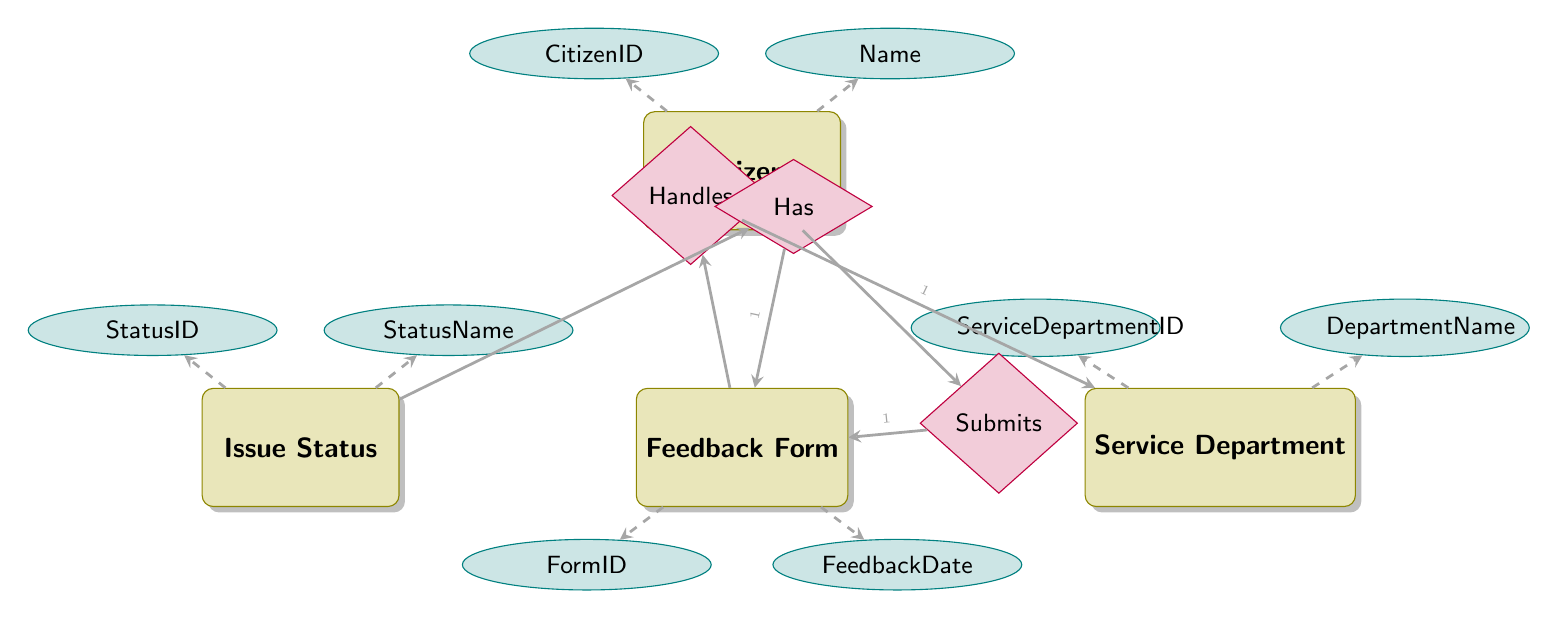What is the ID attribute of the Citizen entity? The attributes listed under the Citizen entity include CitizenID, Name, Address, Email, and Phone. The ID attribute specifically is named CitizenID.
Answer: CitizenID How many entities are in the diagram? The diagram shows four entities: Citizen, Feedback Form, Service Department, and Issue Status. Therefore, the total number of entities is four.
Answer: 4 What relationship type exists between Citizen and Feedback Form? The relationship between Citizen and Feedback Form is labeled as "Submits" and is described as a OneToMany relationship, indicating that one citizen can submit multiple feedback forms.
Answer: OneToMany Which entity handles the feedback forms? The Service Department entity is responsible for handling feedback forms, as indicated by the relationship labeled "Handles" from Feedback Form to Service Department.
Answer: Service Department How many statuses can a Feedback Form have? The diagram shows that each Feedback Form can have one Issue Status as indicated by the OneToMany relationship originating from Issue Status, allowing multiple feedback forms to be linked to a single status.
Answer: Many What is the attribute that links Feedback Form to Service Department? The Feedback Form entity includes an attribute called ServiceDepartmentID that establishes the link to the Service Department entity.
Answer: ServiceDepartmentID What is the relationship between Issue Status and Feedback Form? The relationship indicates that an Issue Status is associated with many Feedback Forms, as suggested by the OneToMany relationship connecting these two entities.
Answer: OneToMany How many attributes does the Service Department entity have? The Service Department entity lists four attributes: ServiceDepartmentID, DepartmentName, ContactEmail, and HeadOfDepartment. Thus, there are four attributes in total.
Answer: 4 